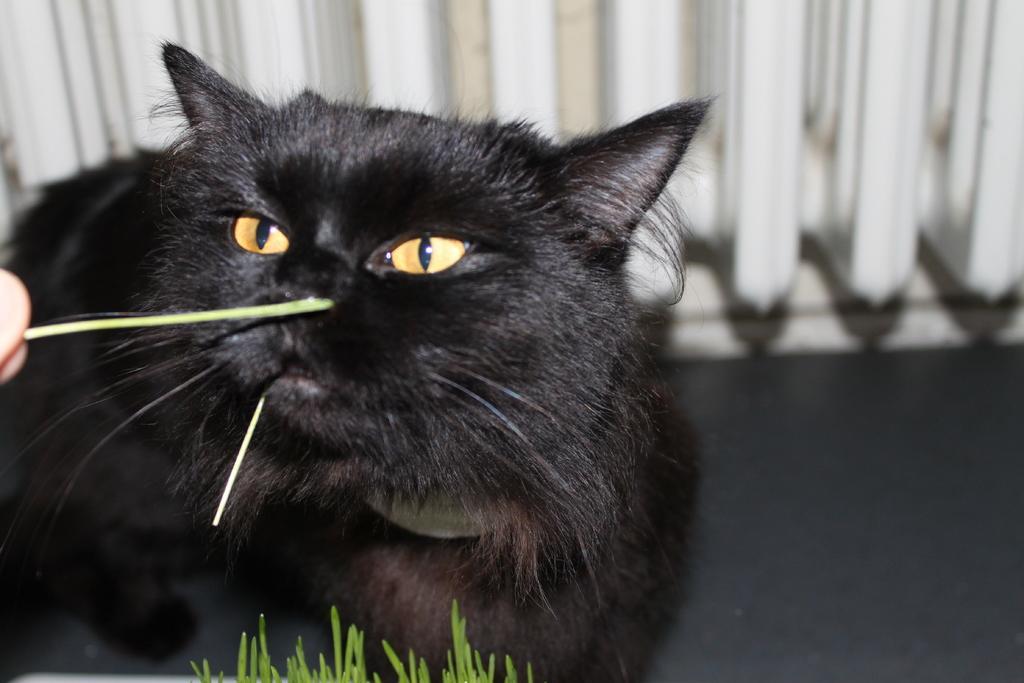How would you summarize this image in a sentence or two? In the middle of the picture we can see a black cat. At the bottom there is grass. On the left we can see a person's finger. At the top there is a white color object. 